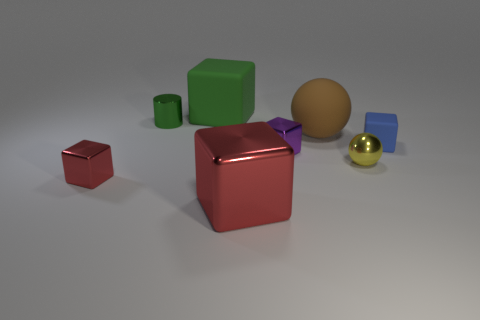Is the color of the cylinder the same as the large rubber cube?
Give a very brief answer. Yes. There is a small thing that is the same color as the large rubber cube; what is its shape?
Offer a very short reply. Cylinder. What size is the block that is the same color as the big metallic object?
Your response must be concise. Small. Is the size of the shiny cylinder the same as the red cube that is in front of the tiny red metal object?
Offer a very short reply. No. There is a large red thing that is the same shape as the small purple object; what material is it?
Give a very brief answer. Metal. What number of small objects are yellow things or brown rubber balls?
Give a very brief answer. 1. What is the material of the small blue thing?
Your answer should be compact. Rubber. The thing that is both on the right side of the small red object and in front of the yellow thing is made of what material?
Give a very brief answer. Metal. There is a large shiny block; is its color the same as the rubber cube that is to the left of the big shiny thing?
Keep it short and to the point. No. There is a purple block that is the same size as the green metal thing; what is its material?
Ensure brevity in your answer.  Metal. 